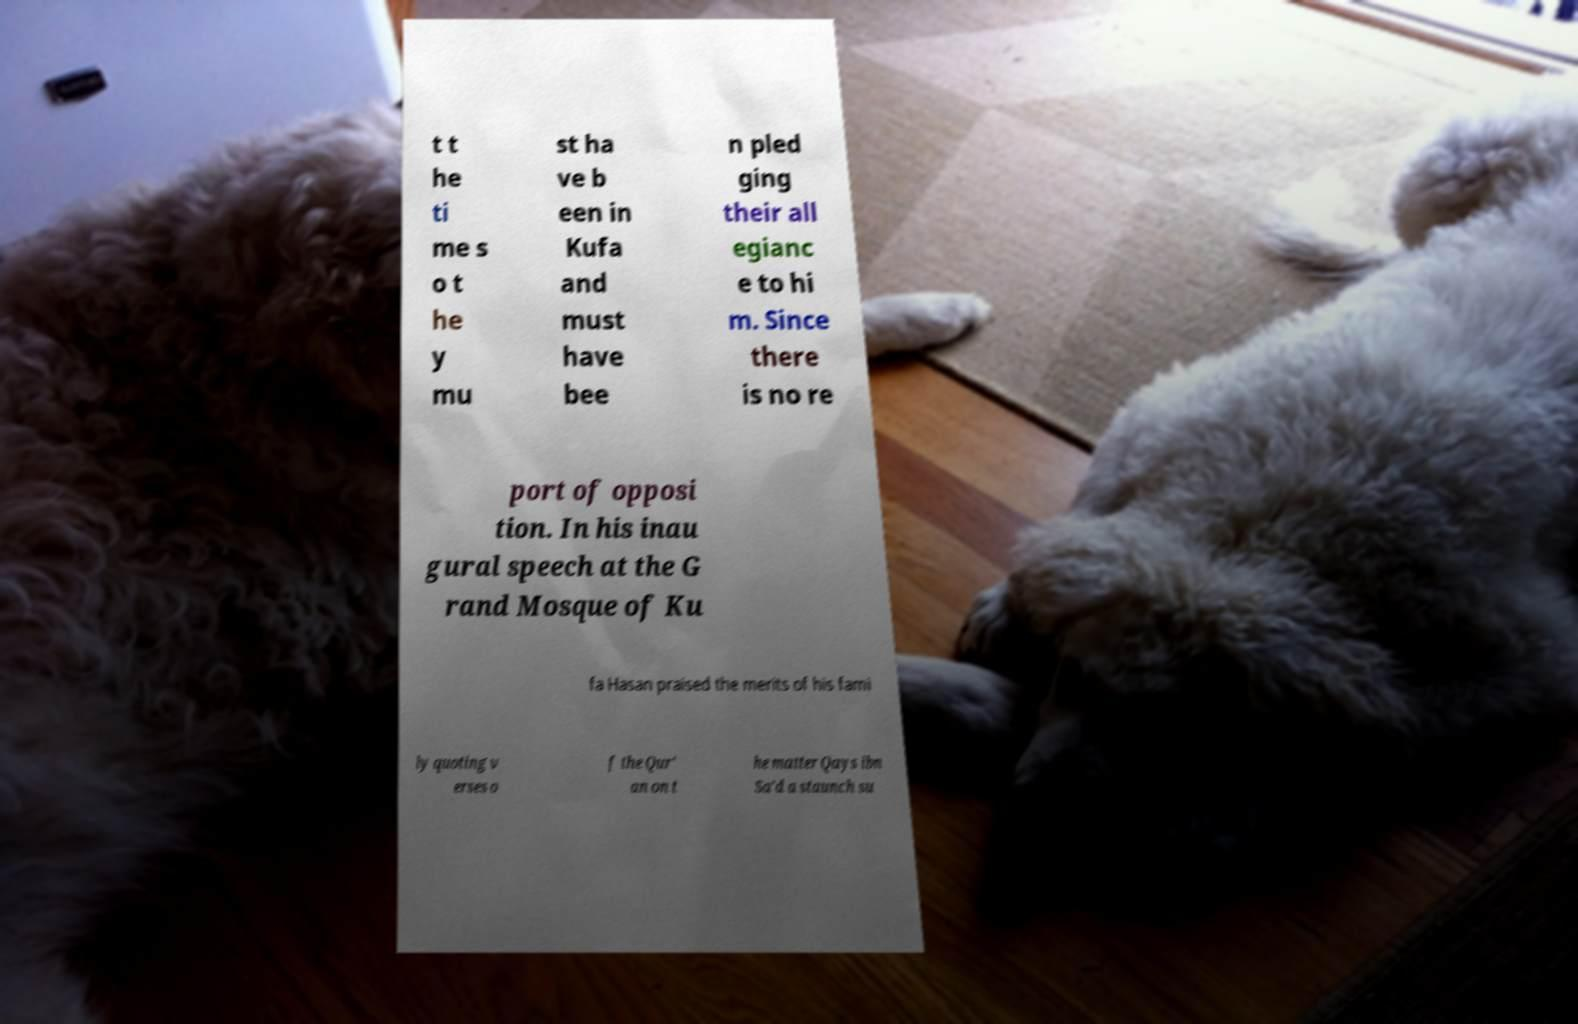Could you extract and type out the text from this image? t t he ti me s o t he y mu st ha ve b een in Kufa and must have bee n pled ging their all egianc e to hi m. Since there is no re port of opposi tion. In his inau gural speech at the G rand Mosque of Ku fa Hasan praised the merits of his fami ly quoting v erses o f the Qur' an on t he matter Qays ibn Sa'd a staunch su 